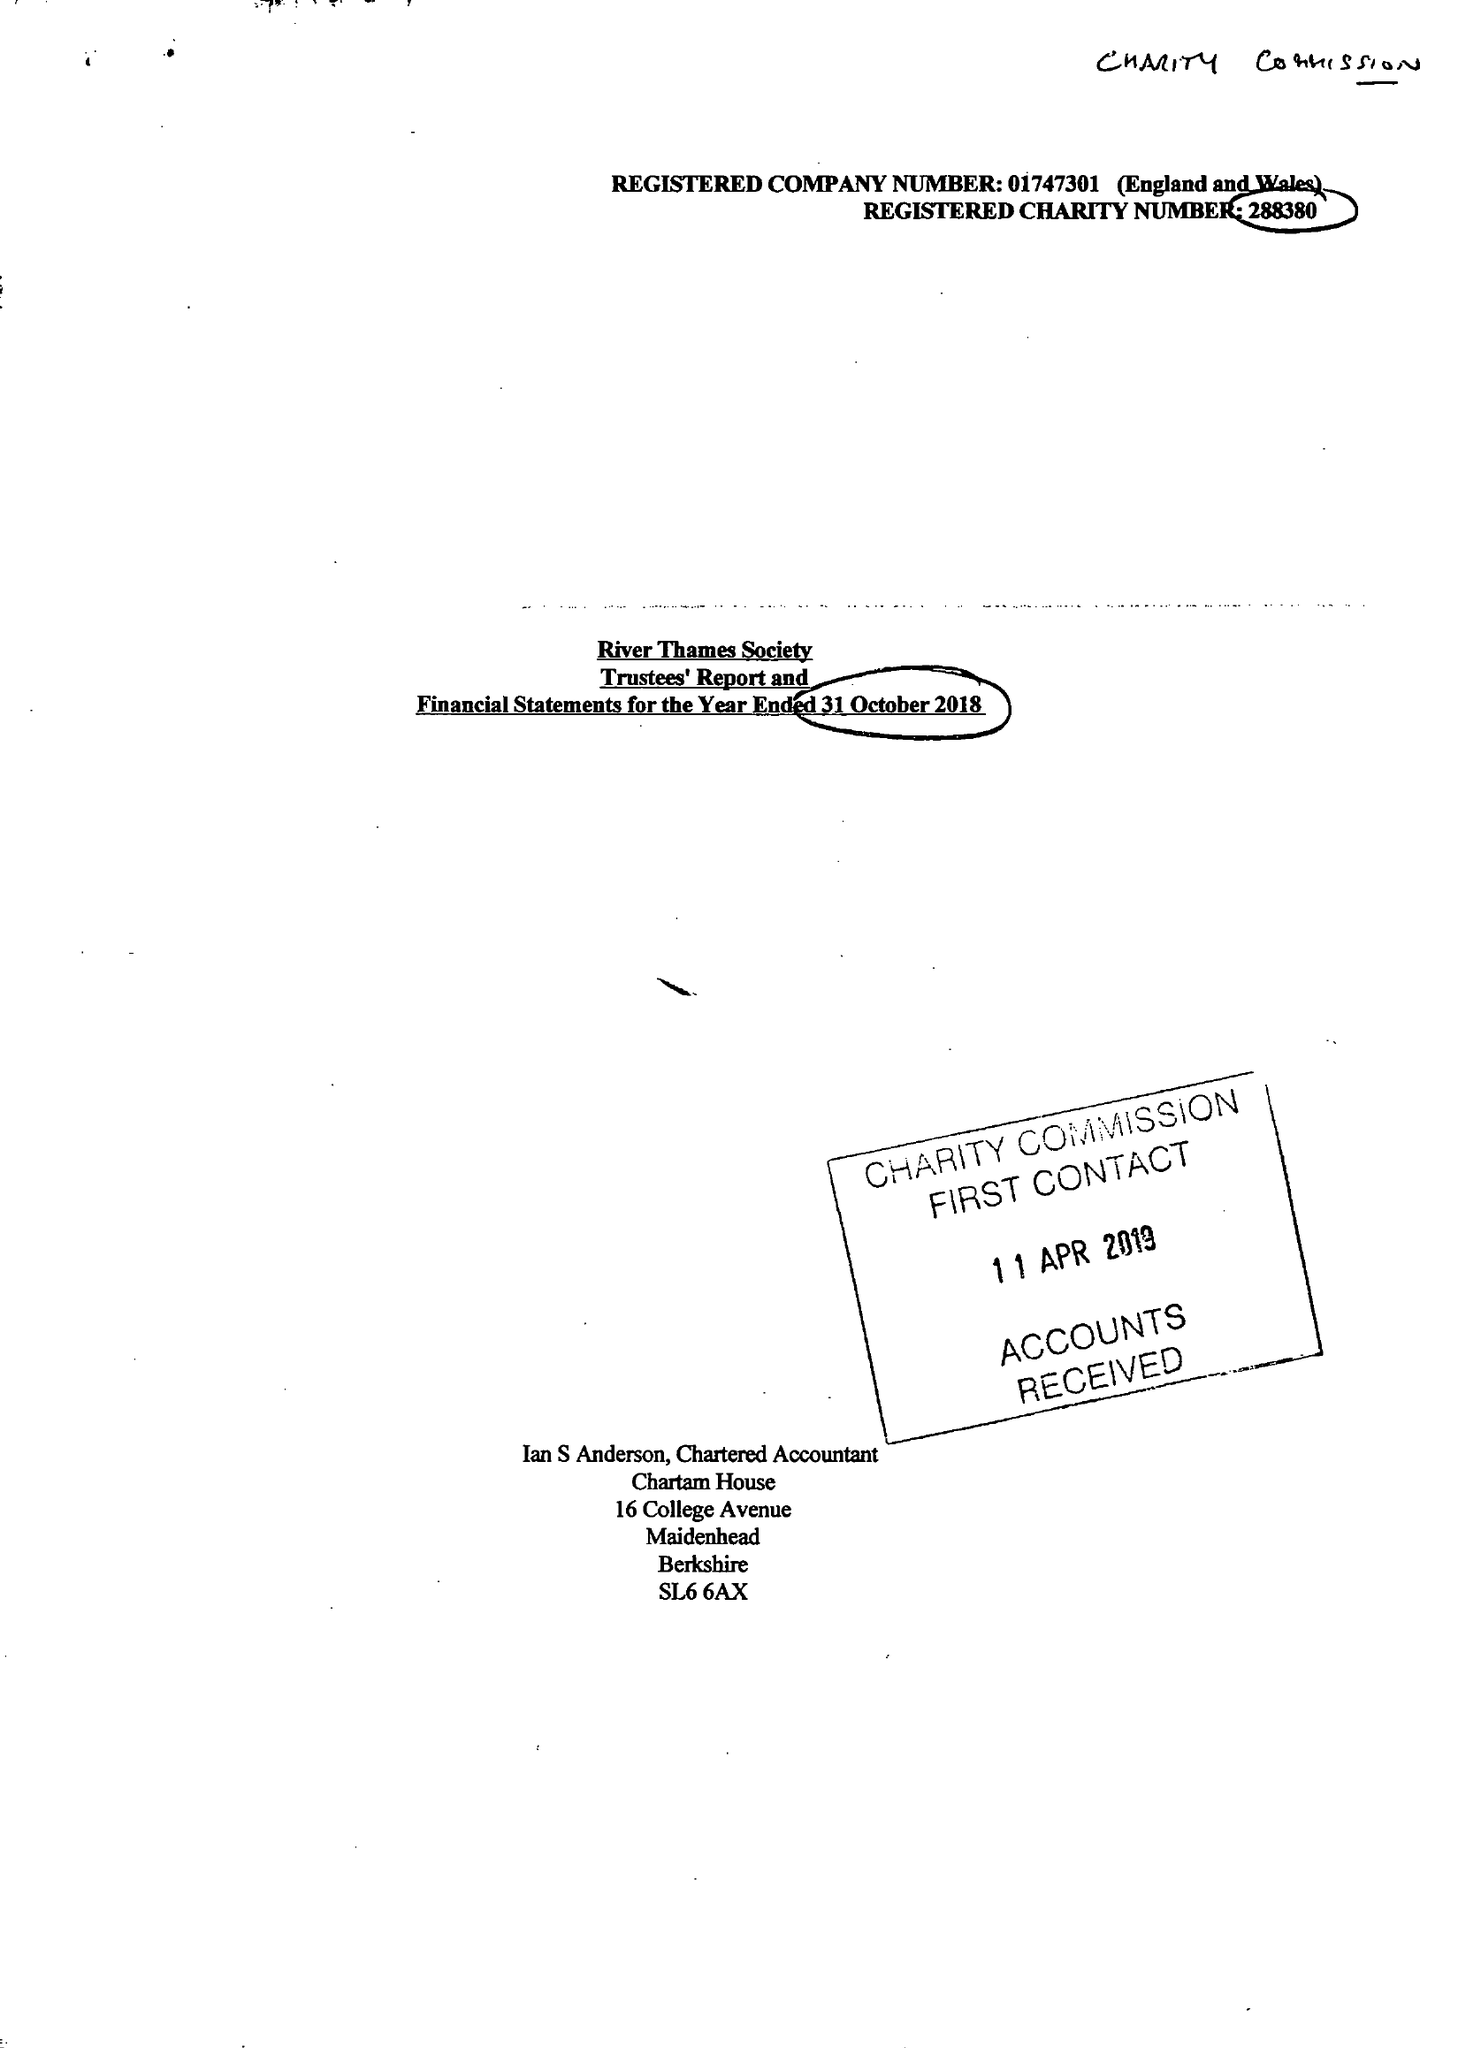What is the value for the spending_annually_in_british_pounds?
Answer the question using a single word or phrase. 39605.00 